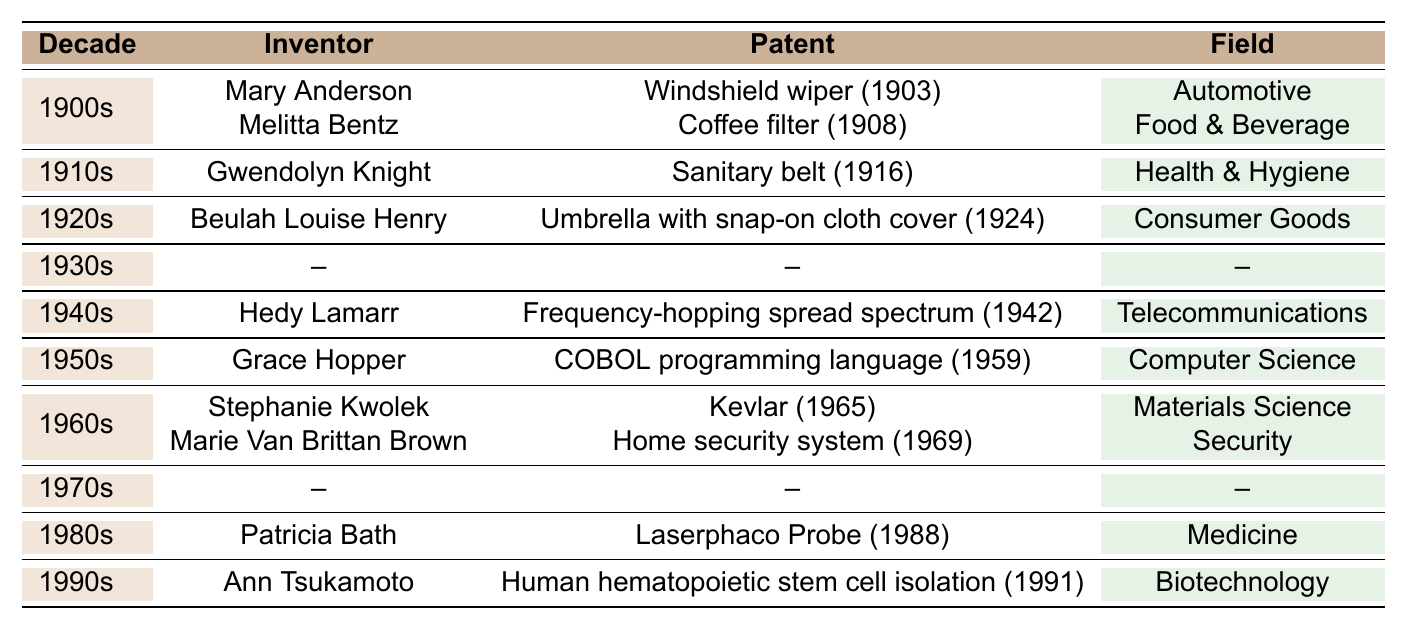What patent did Mary Anderson receive in the 1900s? Mary Anderson received a patent for the windshield wiper in 1903. This information can be found in the "1900s" row of the table.
Answer: Windshield wiper How many women inventors are listed in the 1960s? In the 1960s, there are two women inventors listed: Stephanie Kwolek and Marie Van Brittan Brown, as seen in the "1960s" row.
Answer: 2 What field did Patricia Bath’s invention pertain to? Patricia Bath's invention, the Laserphaco Probe, pertained to the field of Medicine, as noted in the "1980s" row.
Answer: Medicine Did any women inventors receive patents in the 1930s? No women inventors are listed in the 1930s as indicated by the "--" in that row of the table.
Answer: No Which decade had the earliest known patent and what was it for? The earliest patent listed is from the 1900s for the windshield wiper by Mary Anderson, as it was patented in 1903.
Answer: 1900s, windshield wiper What types of fields do the inventions from the table cover? The inventions cover multiple fields including Automotive, Food & Beverage, Health & Hygiene, Consumer Goods, Telecommunications, Computer Science, Security, Medicine, and Biotechnology. This can be seen across all decades listed in the table.
Answer: Various fields How many patents were awarded to women in the 1940s and 1960s combined? One patent was awarded to Hedy Lamarr in the 1940s, and two patents were awarded in the 1960s (to Stephanie Kwolek and Marie Van Brittan Brown). Therefore, the combined total is 1 + 2 = 3 patents.
Answer: 3 What is the common characteristic of the patents awarded in the 1900s? The common characteristic of the patents awarded in the 1900s (windshield wiper and coffee filter) is that they both relate to everyday consumer convenience in transportation and food preparation. This interpretation can be drawn from the nature of the patents listed in that decade.
Answer: Everyday consumer convenience What year did Grace Hopper receive her patent? Grace Hopper received her patent for the COBOL programming language in 1959, as indicated in the "1950s" row of the table.
Answer: 1959 Which inventor made a contribution to both security and medicine fields? No inventor is listed as having made contributions to both the security and medicine fields; each inventor is associated with a single specific field as per the table.
Answer: No 